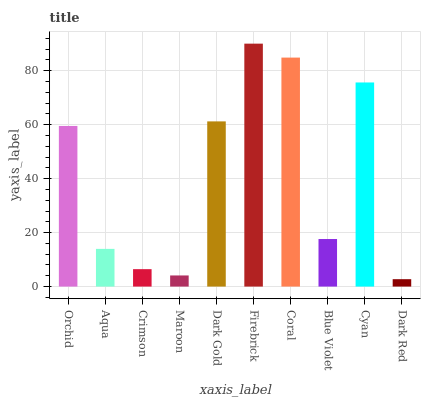Is Dark Red the minimum?
Answer yes or no. Yes. Is Firebrick the maximum?
Answer yes or no. Yes. Is Aqua the minimum?
Answer yes or no. No. Is Aqua the maximum?
Answer yes or no. No. Is Orchid greater than Aqua?
Answer yes or no. Yes. Is Aqua less than Orchid?
Answer yes or no. Yes. Is Aqua greater than Orchid?
Answer yes or no. No. Is Orchid less than Aqua?
Answer yes or no. No. Is Orchid the high median?
Answer yes or no. Yes. Is Blue Violet the low median?
Answer yes or no. Yes. Is Cyan the high median?
Answer yes or no. No. Is Coral the low median?
Answer yes or no. No. 